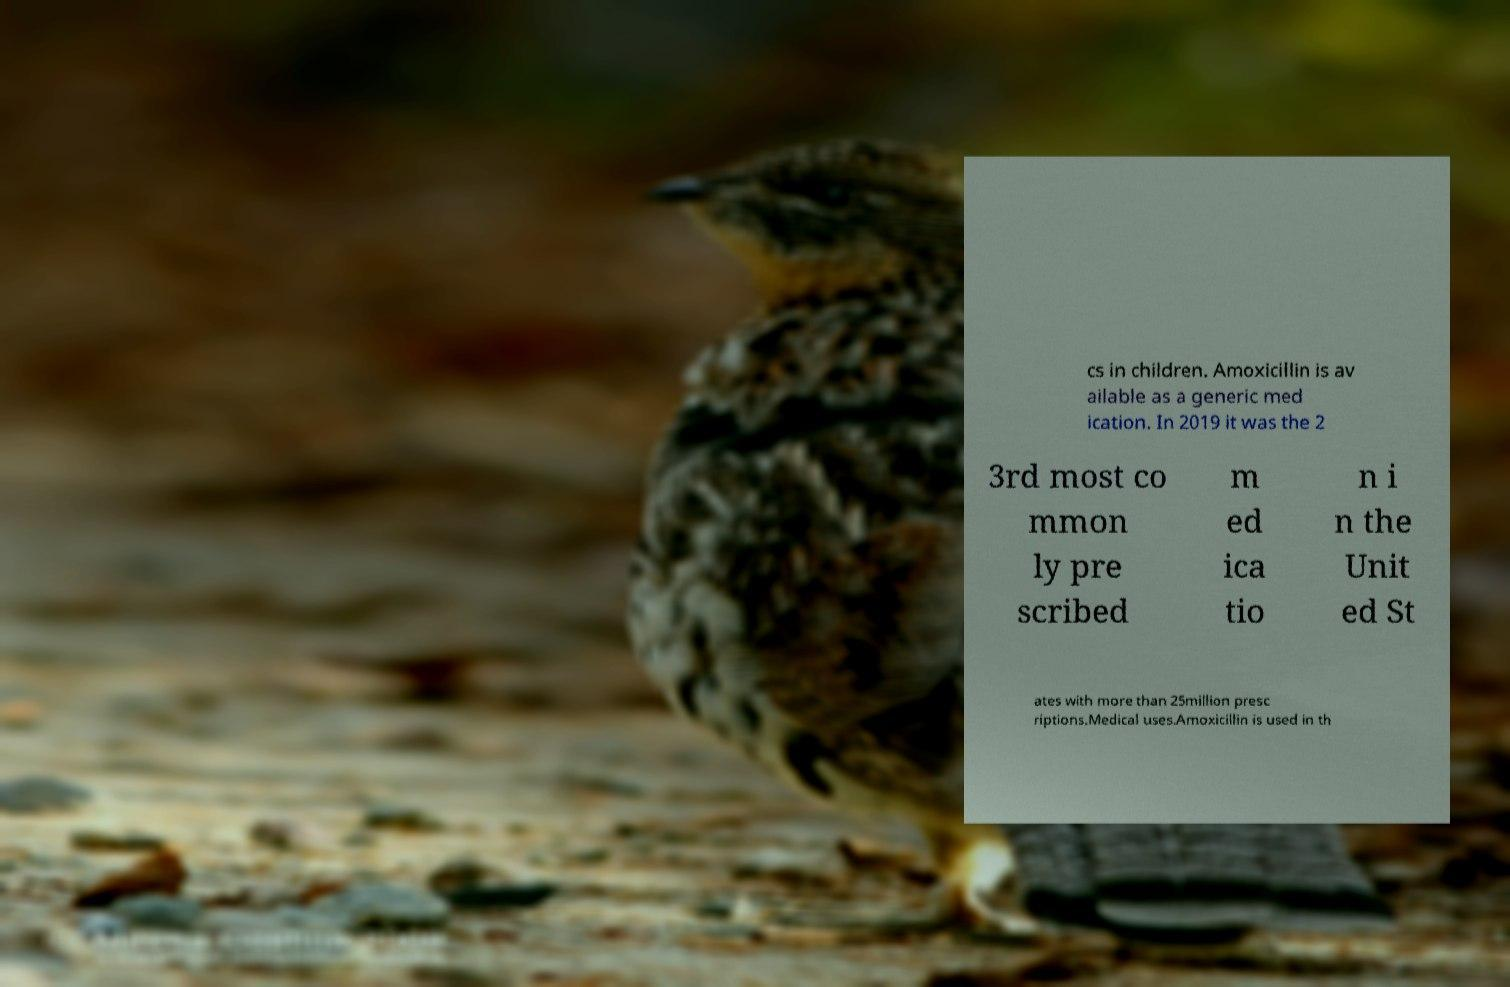Could you extract and type out the text from this image? cs in children. Amoxicillin is av ailable as a generic med ication. In 2019 it was the 2 3rd most co mmon ly pre scribed m ed ica tio n i n the Unit ed St ates with more than 25million presc riptions.Medical uses.Amoxicillin is used in th 